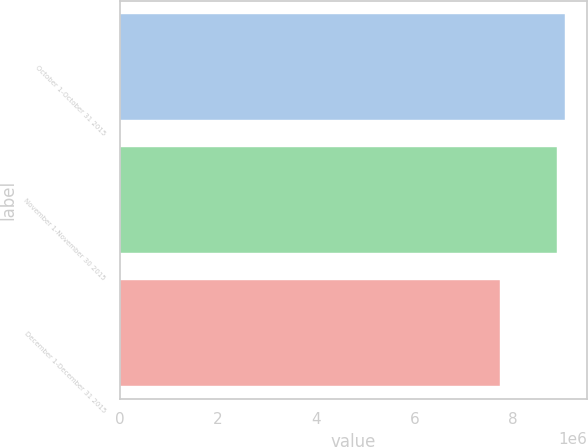<chart> <loc_0><loc_0><loc_500><loc_500><bar_chart><fcel>October 1-October 31 2015<fcel>November 1-November 30 2015<fcel>December 1-December 31 2015<nl><fcel>9.0635e+06<fcel>8.89325e+06<fcel>7.75e+06<nl></chart> 